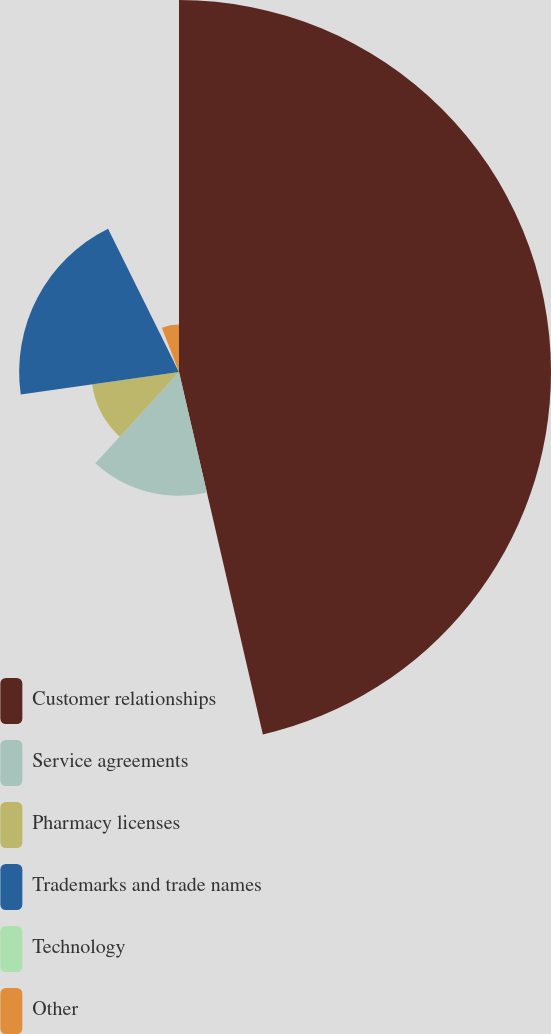<chart> <loc_0><loc_0><loc_500><loc_500><pie_chart><fcel>Customer relationships<fcel>Service agreements<fcel>Pharmacy licenses<fcel>Trademarks and trade names<fcel>Technology<fcel>Other<nl><fcel>46.38%<fcel>15.43%<fcel>10.94%<fcel>19.93%<fcel>1.41%<fcel>5.91%<nl></chart> 